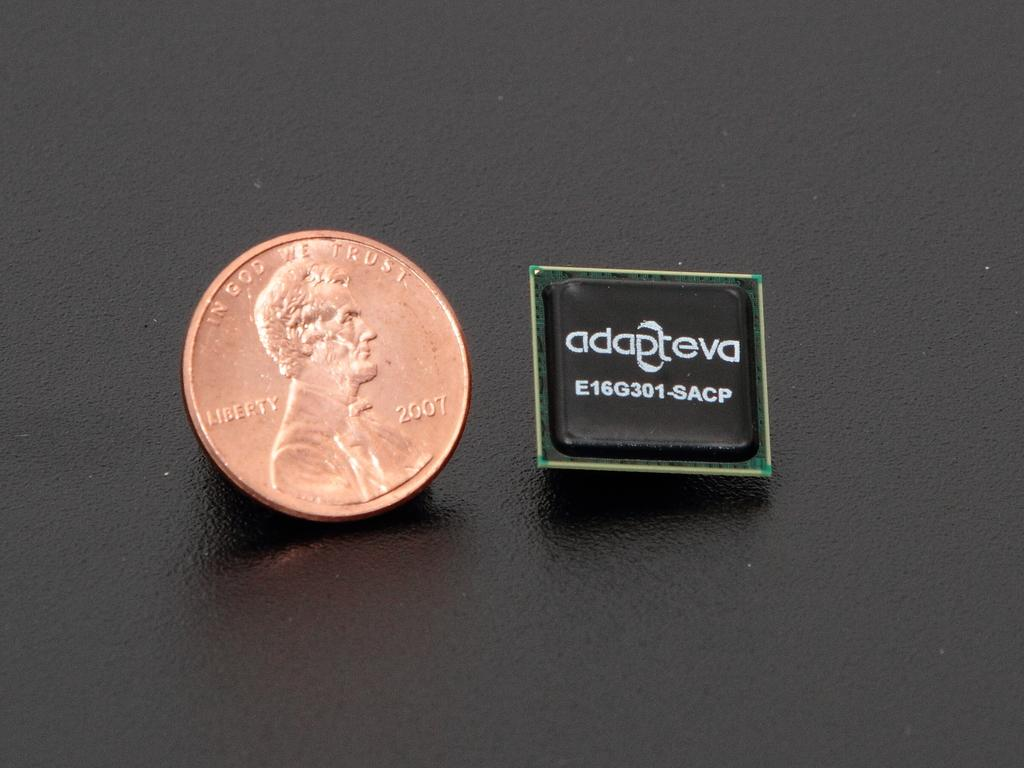<image>
Present a compact description of the photo's key features. A Lincoln penny is next to a square about the same size with adapteva written on it. 